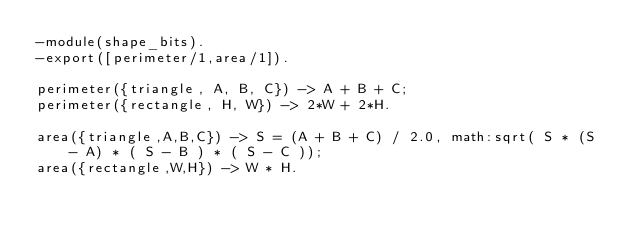Convert code to text. <code><loc_0><loc_0><loc_500><loc_500><_Erlang_>-module(shape_bits).
-export([perimeter/1,area/1]).

perimeter({triangle, A, B, C}) -> A + B + C;
perimeter({rectangle, H, W}) -> 2*W + 2*H.

area({triangle,A,B,C}) -> S = (A + B + C) / 2.0, math:sqrt( S * (S - A) * ( S - B ) * ( S - C ));
area({rectangle,W,H}) -> W * H.</code> 